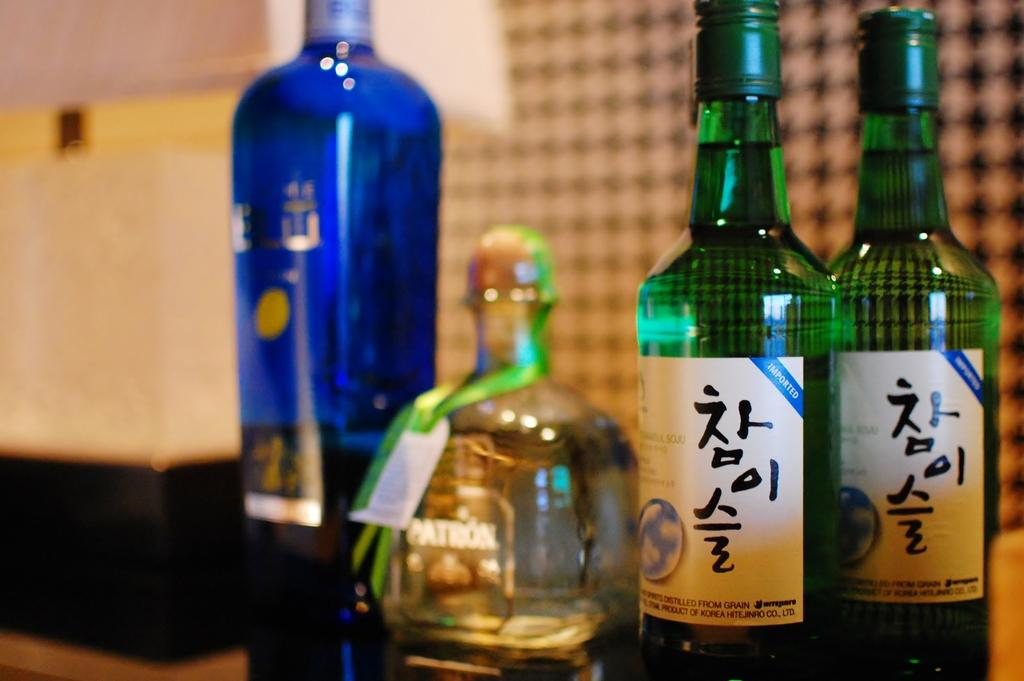<image>
Summarize the visual content of the image. Bottles lined up together include some that are a product of Korea. 